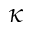<formula> <loc_0><loc_0><loc_500><loc_500>\kappa</formula> 